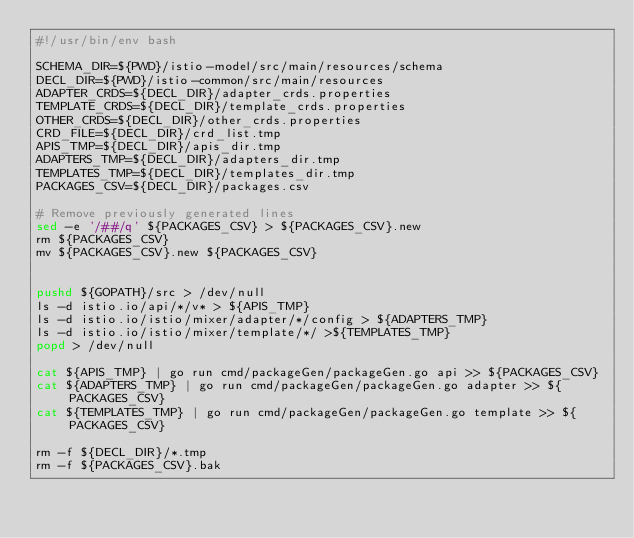<code> <loc_0><loc_0><loc_500><loc_500><_Bash_>#!/usr/bin/env bash

SCHEMA_DIR=${PWD}/istio-model/src/main/resources/schema
DECL_DIR=${PWD}/istio-common/src/main/resources
ADAPTER_CRDS=${DECL_DIR}/adapter_crds.properties
TEMPLATE_CRDS=${DECL_DIR}/template_crds.properties
OTHER_CRDS=${DECL_DIR}/other_crds.properties
CRD_FILE=${DECL_DIR}/crd_list.tmp
APIS_TMP=${DECL_DIR}/apis_dir.tmp
ADAPTERS_TMP=${DECL_DIR}/adapters_dir.tmp
TEMPLATES_TMP=${DECL_DIR}/templates_dir.tmp
PACKAGES_CSV=${DECL_DIR}/packages.csv

# Remove previously generated lines
sed -e '/##/q' ${PACKAGES_CSV} > ${PACKAGES_CSV}.new
rm ${PACKAGES_CSV}
mv ${PACKAGES_CSV}.new ${PACKAGES_CSV}


pushd ${GOPATH}/src > /dev/null
ls -d istio.io/api/*/v* > ${APIS_TMP}
ls -d istio.io/istio/mixer/adapter/*/config > ${ADAPTERS_TMP}
ls -d istio.io/istio/mixer/template/*/ >${TEMPLATES_TMP}
popd > /dev/null

cat ${APIS_TMP} | go run cmd/packageGen/packageGen.go api >> ${PACKAGES_CSV}
cat ${ADAPTERS_TMP} | go run cmd/packageGen/packageGen.go adapter >> ${PACKAGES_CSV}
cat ${TEMPLATES_TMP} | go run cmd/packageGen/packageGen.go template >> ${PACKAGES_CSV}

rm -f ${DECL_DIR}/*.tmp
rm -f ${PACKAGES_CSV}.bak</code> 